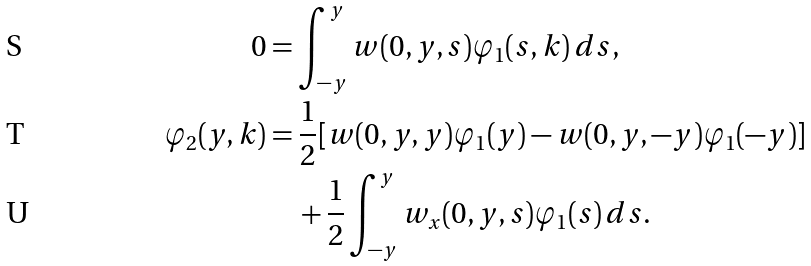Convert formula to latex. <formula><loc_0><loc_0><loc_500><loc_500>0 & = \int ^ { y } _ { - y } w ( 0 , y , s ) \varphi _ { 1 } ( s , k ) \, d s , \\ \varphi _ { 2 } ( y , k ) & = \frac { 1 } { 2 } [ w ( 0 , y , y ) \varphi _ { 1 } ( y ) - w ( 0 , y , - y ) \varphi _ { 1 } ( - y ) ] \\ & \quad + \frac { 1 } { 2 } \int ^ { y } _ { - y } w _ { x } ( 0 , y , s ) \varphi _ { 1 } ( s ) \, d s .</formula> 